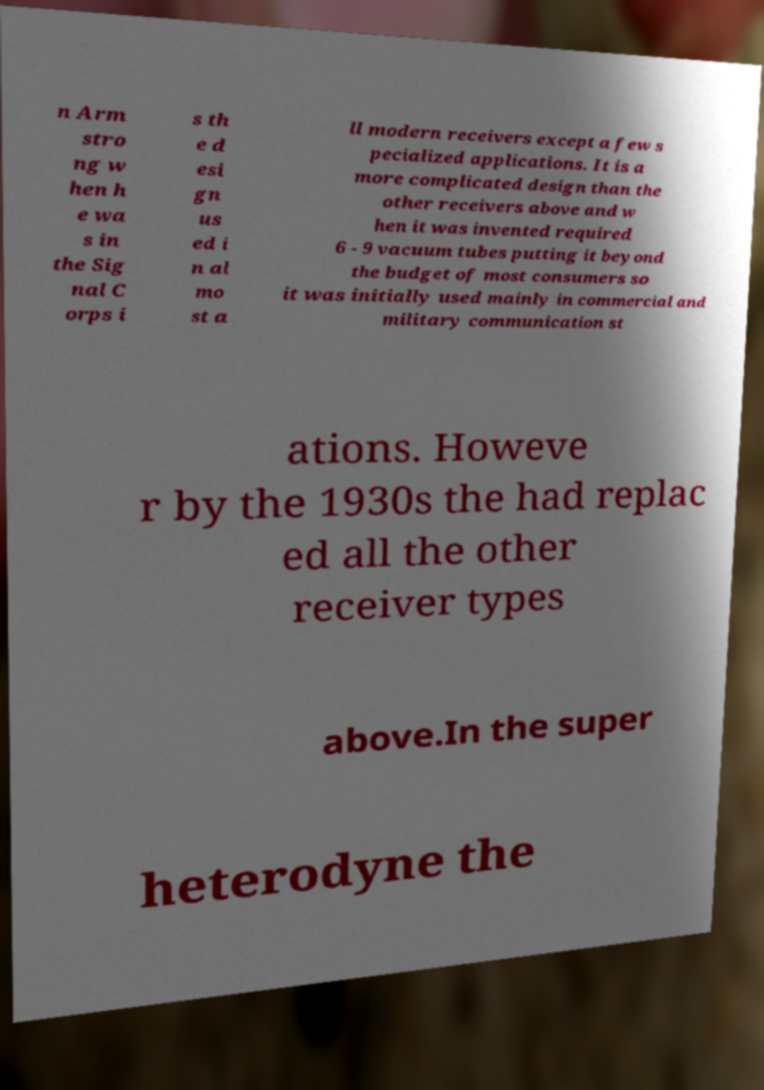Please read and relay the text visible in this image. What does it say? n Arm stro ng w hen h e wa s in the Sig nal C orps i s th e d esi gn us ed i n al mo st a ll modern receivers except a few s pecialized applications. It is a more complicated design than the other receivers above and w hen it was invented required 6 - 9 vacuum tubes putting it beyond the budget of most consumers so it was initially used mainly in commercial and military communication st ations. Howeve r by the 1930s the had replac ed all the other receiver types above.In the super heterodyne the 